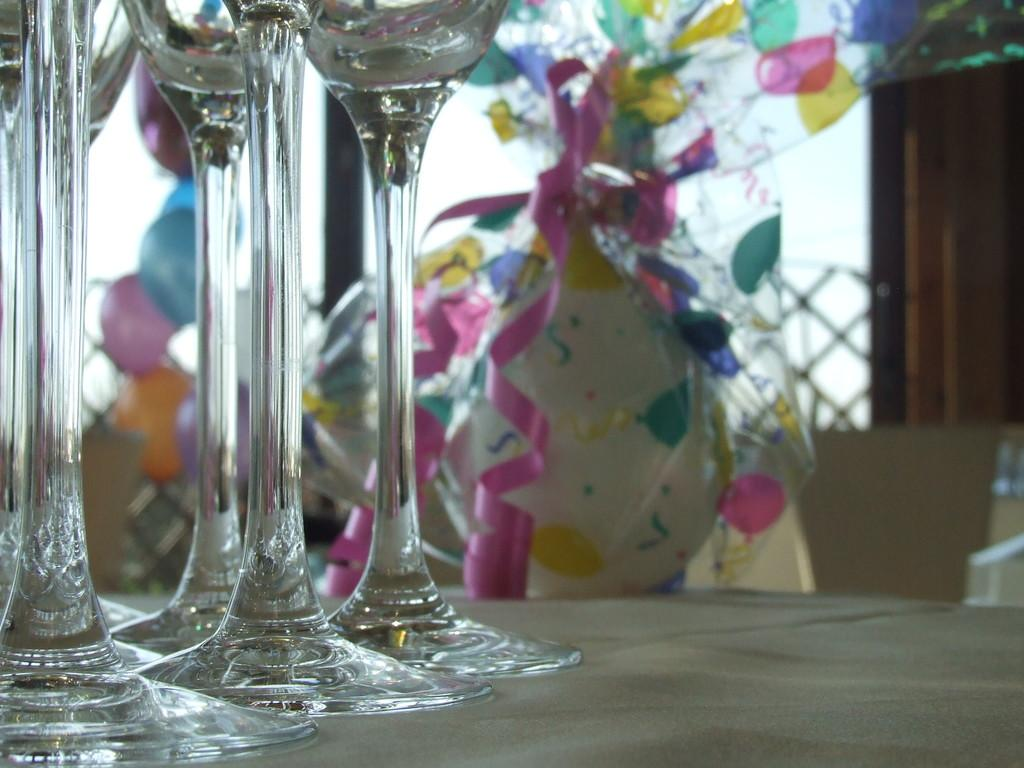What type of glasses are visible in the image? There are wine glasses in the image. Where are the wine glasses located in the image? The wine glasses are positioned at the bottom part of the image. What else can be seen on the table in the image? There are gifts on a table in the image. What type of drum can be seen in the image? There is no drum present in the image. What color are the marbles on the table in the image? There are no marbles present in the image. 